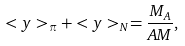<formula> <loc_0><loc_0><loc_500><loc_500>< y > _ { \pi } + < y > _ { N } = \frac { M _ { A } } { A M } ,</formula> 